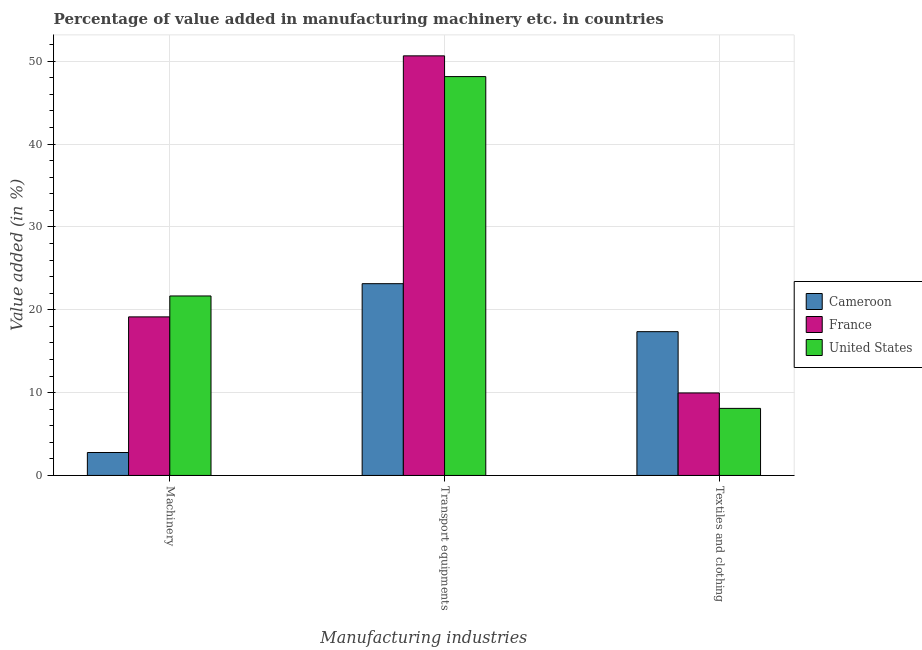How many different coloured bars are there?
Make the answer very short. 3. How many groups of bars are there?
Provide a short and direct response. 3. Are the number of bars per tick equal to the number of legend labels?
Offer a terse response. Yes. Are the number of bars on each tick of the X-axis equal?
Give a very brief answer. Yes. How many bars are there on the 3rd tick from the right?
Ensure brevity in your answer.  3. What is the label of the 1st group of bars from the left?
Make the answer very short. Machinery. What is the value added in manufacturing textile and clothing in Cameroon?
Offer a very short reply. 17.36. Across all countries, what is the maximum value added in manufacturing transport equipments?
Your response must be concise. 50.66. Across all countries, what is the minimum value added in manufacturing textile and clothing?
Your answer should be compact. 8.1. In which country was the value added in manufacturing machinery minimum?
Keep it short and to the point. Cameroon. What is the total value added in manufacturing transport equipments in the graph?
Your answer should be very brief. 121.96. What is the difference between the value added in manufacturing machinery in France and that in United States?
Offer a very short reply. -2.52. What is the difference between the value added in manufacturing machinery in United States and the value added in manufacturing transport equipments in Cameroon?
Keep it short and to the point. -1.48. What is the average value added in manufacturing textile and clothing per country?
Your answer should be compact. 11.8. What is the difference between the value added in manufacturing transport equipments and value added in manufacturing machinery in France?
Offer a very short reply. 31.51. In how many countries, is the value added in manufacturing machinery greater than 44 %?
Make the answer very short. 0. What is the ratio of the value added in manufacturing machinery in Cameroon to that in United States?
Keep it short and to the point. 0.13. Is the value added in manufacturing machinery in United States less than that in Cameroon?
Offer a very short reply. No. Is the difference between the value added in manufacturing textile and clothing in France and Cameroon greater than the difference between the value added in manufacturing transport equipments in France and Cameroon?
Provide a succinct answer. No. What is the difference between the highest and the second highest value added in manufacturing textile and clothing?
Make the answer very short. 7.4. What is the difference between the highest and the lowest value added in manufacturing transport equipments?
Your answer should be compact. 27.51. Is the sum of the value added in manufacturing machinery in United States and France greater than the maximum value added in manufacturing textile and clothing across all countries?
Provide a short and direct response. Yes. What does the 1st bar from the left in Machinery represents?
Keep it short and to the point. Cameroon. What does the 2nd bar from the right in Textiles and clothing represents?
Provide a succinct answer. France. Is it the case that in every country, the sum of the value added in manufacturing machinery and value added in manufacturing transport equipments is greater than the value added in manufacturing textile and clothing?
Ensure brevity in your answer.  Yes. Are all the bars in the graph horizontal?
Provide a succinct answer. No. How many countries are there in the graph?
Keep it short and to the point. 3. Are the values on the major ticks of Y-axis written in scientific E-notation?
Make the answer very short. No. Does the graph contain grids?
Your answer should be very brief. Yes. Where does the legend appear in the graph?
Offer a very short reply. Center right. How many legend labels are there?
Your response must be concise. 3. How are the legend labels stacked?
Your answer should be compact. Vertical. What is the title of the graph?
Offer a very short reply. Percentage of value added in manufacturing machinery etc. in countries. Does "India" appear as one of the legend labels in the graph?
Your response must be concise. No. What is the label or title of the X-axis?
Keep it short and to the point. Manufacturing industries. What is the label or title of the Y-axis?
Your response must be concise. Value added (in %). What is the Value added (in %) in Cameroon in Machinery?
Your response must be concise. 2.77. What is the Value added (in %) of France in Machinery?
Offer a very short reply. 19.14. What is the Value added (in %) of United States in Machinery?
Provide a short and direct response. 21.67. What is the Value added (in %) in Cameroon in Transport equipments?
Give a very brief answer. 23.15. What is the Value added (in %) in France in Transport equipments?
Provide a succinct answer. 50.66. What is the Value added (in %) in United States in Transport equipments?
Make the answer very short. 48.15. What is the Value added (in %) in Cameroon in Textiles and clothing?
Your answer should be compact. 17.36. What is the Value added (in %) in France in Textiles and clothing?
Offer a terse response. 9.96. What is the Value added (in %) in United States in Textiles and clothing?
Make the answer very short. 8.1. Across all Manufacturing industries, what is the maximum Value added (in %) of Cameroon?
Ensure brevity in your answer.  23.15. Across all Manufacturing industries, what is the maximum Value added (in %) in France?
Keep it short and to the point. 50.66. Across all Manufacturing industries, what is the maximum Value added (in %) of United States?
Your answer should be very brief. 48.15. Across all Manufacturing industries, what is the minimum Value added (in %) of Cameroon?
Offer a terse response. 2.77. Across all Manufacturing industries, what is the minimum Value added (in %) in France?
Make the answer very short. 9.96. Across all Manufacturing industries, what is the minimum Value added (in %) of United States?
Provide a short and direct response. 8.1. What is the total Value added (in %) in Cameroon in the graph?
Keep it short and to the point. 43.28. What is the total Value added (in %) in France in the graph?
Your answer should be very brief. 79.76. What is the total Value added (in %) in United States in the graph?
Keep it short and to the point. 77.92. What is the difference between the Value added (in %) in Cameroon in Machinery and that in Transport equipments?
Ensure brevity in your answer.  -20.38. What is the difference between the Value added (in %) of France in Machinery and that in Transport equipments?
Provide a succinct answer. -31.51. What is the difference between the Value added (in %) of United States in Machinery and that in Transport equipments?
Make the answer very short. -26.49. What is the difference between the Value added (in %) in Cameroon in Machinery and that in Textiles and clothing?
Your answer should be very brief. -14.59. What is the difference between the Value added (in %) of France in Machinery and that in Textiles and clothing?
Give a very brief answer. 9.18. What is the difference between the Value added (in %) in United States in Machinery and that in Textiles and clothing?
Offer a terse response. 13.57. What is the difference between the Value added (in %) in Cameroon in Transport equipments and that in Textiles and clothing?
Ensure brevity in your answer.  5.79. What is the difference between the Value added (in %) in France in Transport equipments and that in Textiles and clothing?
Your answer should be compact. 40.7. What is the difference between the Value added (in %) of United States in Transport equipments and that in Textiles and clothing?
Ensure brevity in your answer.  40.06. What is the difference between the Value added (in %) of Cameroon in Machinery and the Value added (in %) of France in Transport equipments?
Your answer should be compact. -47.89. What is the difference between the Value added (in %) in Cameroon in Machinery and the Value added (in %) in United States in Transport equipments?
Offer a terse response. -45.38. What is the difference between the Value added (in %) of France in Machinery and the Value added (in %) of United States in Transport equipments?
Give a very brief answer. -29.01. What is the difference between the Value added (in %) of Cameroon in Machinery and the Value added (in %) of France in Textiles and clothing?
Keep it short and to the point. -7.19. What is the difference between the Value added (in %) in Cameroon in Machinery and the Value added (in %) in United States in Textiles and clothing?
Provide a short and direct response. -5.33. What is the difference between the Value added (in %) in France in Machinery and the Value added (in %) in United States in Textiles and clothing?
Give a very brief answer. 11.05. What is the difference between the Value added (in %) in Cameroon in Transport equipments and the Value added (in %) in France in Textiles and clothing?
Offer a terse response. 13.19. What is the difference between the Value added (in %) in Cameroon in Transport equipments and the Value added (in %) in United States in Textiles and clothing?
Provide a short and direct response. 15.06. What is the difference between the Value added (in %) of France in Transport equipments and the Value added (in %) of United States in Textiles and clothing?
Ensure brevity in your answer.  42.56. What is the average Value added (in %) in Cameroon per Manufacturing industries?
Offer a terse response. 14.43. What is the average Value added (in %) of France per Manufacturing industries?
Offer a terse response. 26.59. What is the average Value added (in %) in United States per Manufacturing industries?
Give a very brief answer. 25.97. What is the difference between the Value added (in %) in Cameroon and Value added (in %) in France in Machinery?
Keep it short and to the point. -16.37. What is the difference between the Value added (in %) in Cameroon and Value added (in %) in United States in Machinery?
Offer a terse response. -18.9. What is the difference between the Value added (in %) in France and Value added (in %) in United States in Machinery?
Keep it short and to the point. -2.52. What is the difference between the Value added (in %) in Cameroon and Value added (in %) in France in Transport equipments?
Give a very brief answer. -27.51. What is the difference between the Value added (in %) in Cameroon and Value added (in %) in United States in Transport equipments?
Give a very brief answer. -25. What is the difference between the Value added (in %) of France and Value added (in %) of United States in Transport equipments?
Offer a very short reply. 2.5. What is the difference between the Value added (in %) of Cameroon and Value added (in %) of France in Textiles and clothing?
Your response must be concise. 7.4. What is the difference between the Value added (in %) of Cameroon and Value added (in %) of United States in Textiles and clothing?
Give a very brief answer. 9.26. What is the difference between the Value added (in %) in France and Value added (in %) in United States in Textiles and clothing?
Provide a short and direct response. 1.86. What is the ratio of the Value added (in %) of Cameroon in Machinery to that in Transport equipments?
Give a very brief answer. 0.12. What is the ratio of the Value added (in %) of France in Machinery to that in Transport equipments?
Make the answer very short. 0.38. What is the ratio of the Value added (in %) of United States in Machinery to that in Transport equipments?
Your answer should be very brief. 0.45. What is the ratio of the Value added (in %) of Cameroon in Machinery to that in Textiles and clothing?
Offer a terse response. 0.16. What is the ratio of the Value added (in %) in France in Machinery to that in Textiles and clothing?
Give a very brief answer. 1.92. What is the ratio of the Value added (in %) in United States in Machinery to that in Textiles and clothing?
Ensure brevity in your answer.  2.68. What is the ratio of the Value added (in %) of Cameroon in Transport equipments to that in Textiles and clothing?
Offer a terse response. 1.33. What is the ratio of the Value added (in %) in France in Transport equipments to that in Textiles and clothing?
Make the answer very short. 5.09. What is the ratio of the Value added (in %) in United States in Transport equipments to that in Textiles and clothing?
Offer a terse response. 5.95. What is the difference between the highest and the second highest Value added (in %) in Cameroon?
Ensure brevity in your answer.  5.79. What is the difference between the highest and the second highest Value added (in %) in France?
Offer a terse response. 31.51. What is the difference between the highest and the second highest Value added (in %) in United States?
Keep it short and to the point. 26.49. What is the difference between the highest and the lowest Value added (in %) of Cameroon?
Provide a short and direct response. 20.38. What is the difference between the highest and the lowest Value added (in %) of France?
Keep it short and to the point. 40.7. What is the difference between the highest and the lowest Value added (in %) in United States?
Give a very brief answer. 40.06. 